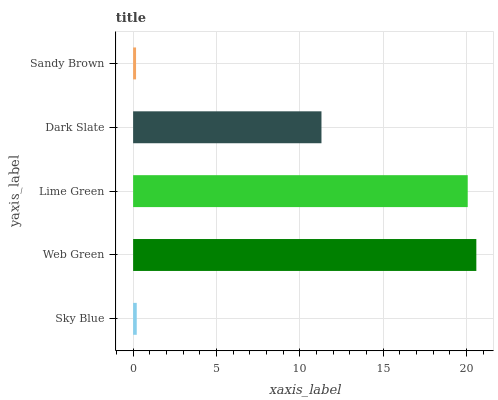Is Sandy Brown the minimum?
Answer yes or no. Yes. Is Web Green the maximum?
Answer yes or no. Yes. Is Lime Green the minimum?
Answer yes or no. No. Is Lime Green the maximum?
Answer yes or no. No. Is Web Green greater than Lime Green?
Answer yes or no. Yes. Is Lime Green less than Web Green?
Answer yes or no. Yes. Is Lime Green greater than Web Green?
Answer yes or no. No. Is Web Green less than Lime Green?
Answer yes or no. No. Is Dark Slate the high median?
Answer yes or no. Yes. Is Dark Slate the low median?
Answer yes or no. Yes. Is Sandy Brown the high median?
Answer yes or no. No. Is Web Green the low median?
Answer yes or no. No. 